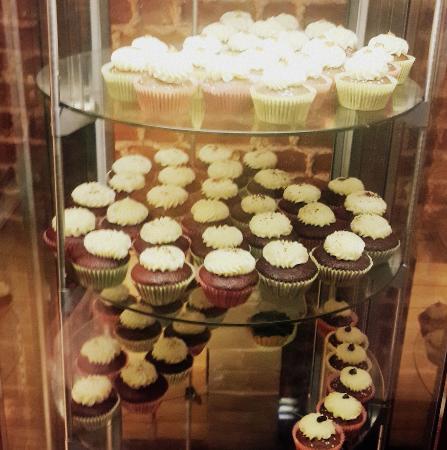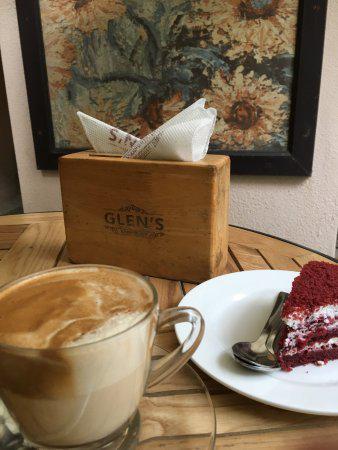The first image is the image on the left, the second image is the image on the right. Assess this claim about the two images: "There is a plate of dessert on top of a wooden round table.". Correct or not? Answer yes or no. Yes. The first image is the image on the left, the second image is the image on the right. Examine the images to the left and right. Is the description "A glass case holds at least two whole, unsliced red velvet cakes." accurate? Answer yes or no. No. 